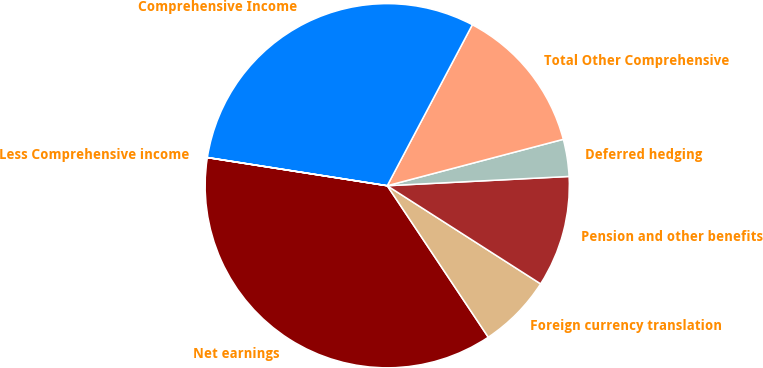Convert chart to OTSL. <chart><loc_0><loc_0><loc_500><loc_500><pie_chart><fcel>Net earnings<fcel>Foreign currency translation<fcel>Pension and other benefits<fcel>Deferred hedging<fcel>Total Other Comprehensive<fcel>Comprehensive Income<fcel>Less Comprehensive income<nl><fcel>36.83%<fcel>6.58%<fcel>9.87%<fcel>3.29%<fcel>13.16%<fcel>30.26%<fcel>0.01%<nl></chart> 